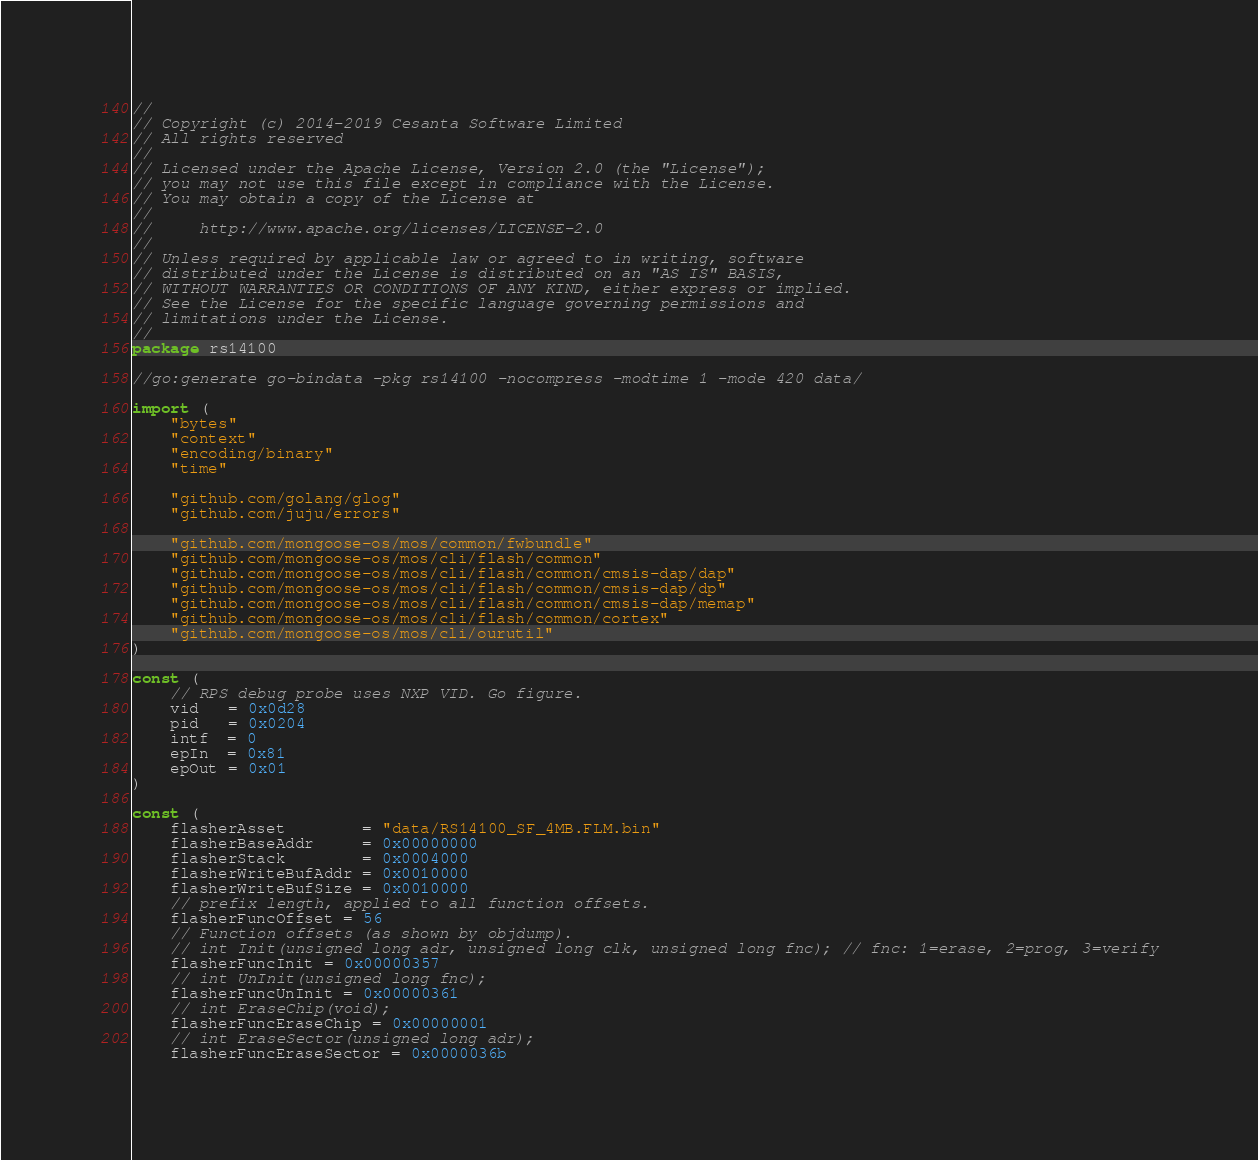<code> <loc_0><loc_0><loc_500><loc_500><_Go_>//
// Copyright (c) 2014-2019 Cesanta Software Limited
// All rights reserved
//
// Licensed under the Apache License, Version 2.0 (the "License");
// you may not use this file except in compliance with the License.
// You may obtain a copy of the License at
//
//     http://www.apache.org/licenses/LICENSE-2.0
//
// Unless required by applicable law or agreed to in writing, software
// distributed under the License is distributed on an "AS IS" BASIS,
// WITHOUT WARRANTIES OR CONDITIONS OF ANY KIND, either express or implied.
// See the License for the specific language governing permissions and
// limitations under the License.
//
package rs14100

//go:generate go-bindata -pkg rs14100 -nocompress -modtime 1 -mode 420 data/

import (
	"bytes"
	"context"
	"encoding/binary"
	"time"

	"github.com/golang/glog"
	"github.com/juju/errors"

	"github.com/mongoose-os/mos/common/fwbundle"
	"github.com/mongoose-os/mos/cli/flash/common"
	"github.com/mongoose-os/mos/cli/flash/common/cmsis-dap/dap"
	"github.com/mongoose-os/mos/cli/flash/common/cmsis-dap/dp"
	"github.com/mongoose-os/mos/cli/flash/common/cmsis-dap/memap"
	"github.com/mongoose-os/mos/cli/flash/common/cortex"
	"github.com/mongoose-os/mos/cli/ourutil"
)

const (
	// RPS debug probe uses NXP VID. Go figure.
	vid   = 0x0d28
	pid   = 0x0204
	intf  = 0
	epIn  = 0x81
	epOut = 0x01
)

const (
	flasherAsset        = "data/RS14100_SF_4MB.FLM.bin"
	flasherBaseAddr     = 0x00000000
	flasherStack        = 0x0004000
	flasherWriteBufAddr = 0x0010000
	flasherWriteBufSize = 0x0010000
	// prefix length, applied to all function offsets.
	flasherFuncOffset = 56
	// Function offsets (as shown by objdump).
	// int Init(unsigned long adr, unsigned long clk, unsigned long fnc); // fnc: 1=erase, 2=prog, 3=verify
	flasherFuncInit = 0x00000357
	// int UnInit(unsigned long fnc);
	flasherFuncUnInit = 0x00000361
	// int EraseChip(void);
	flasherFuncEraseChip = 0x00000001
	// int EraseSector(unsigned long adr);
	flasherFuncEraseSector = 0x0000036b</code> 